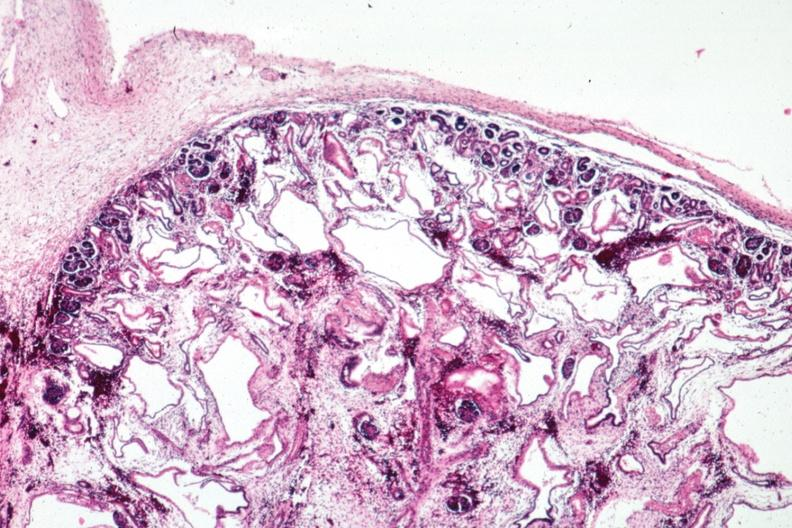what is present?
Answer the question using a single word or phrase. Polycystic disease infant 